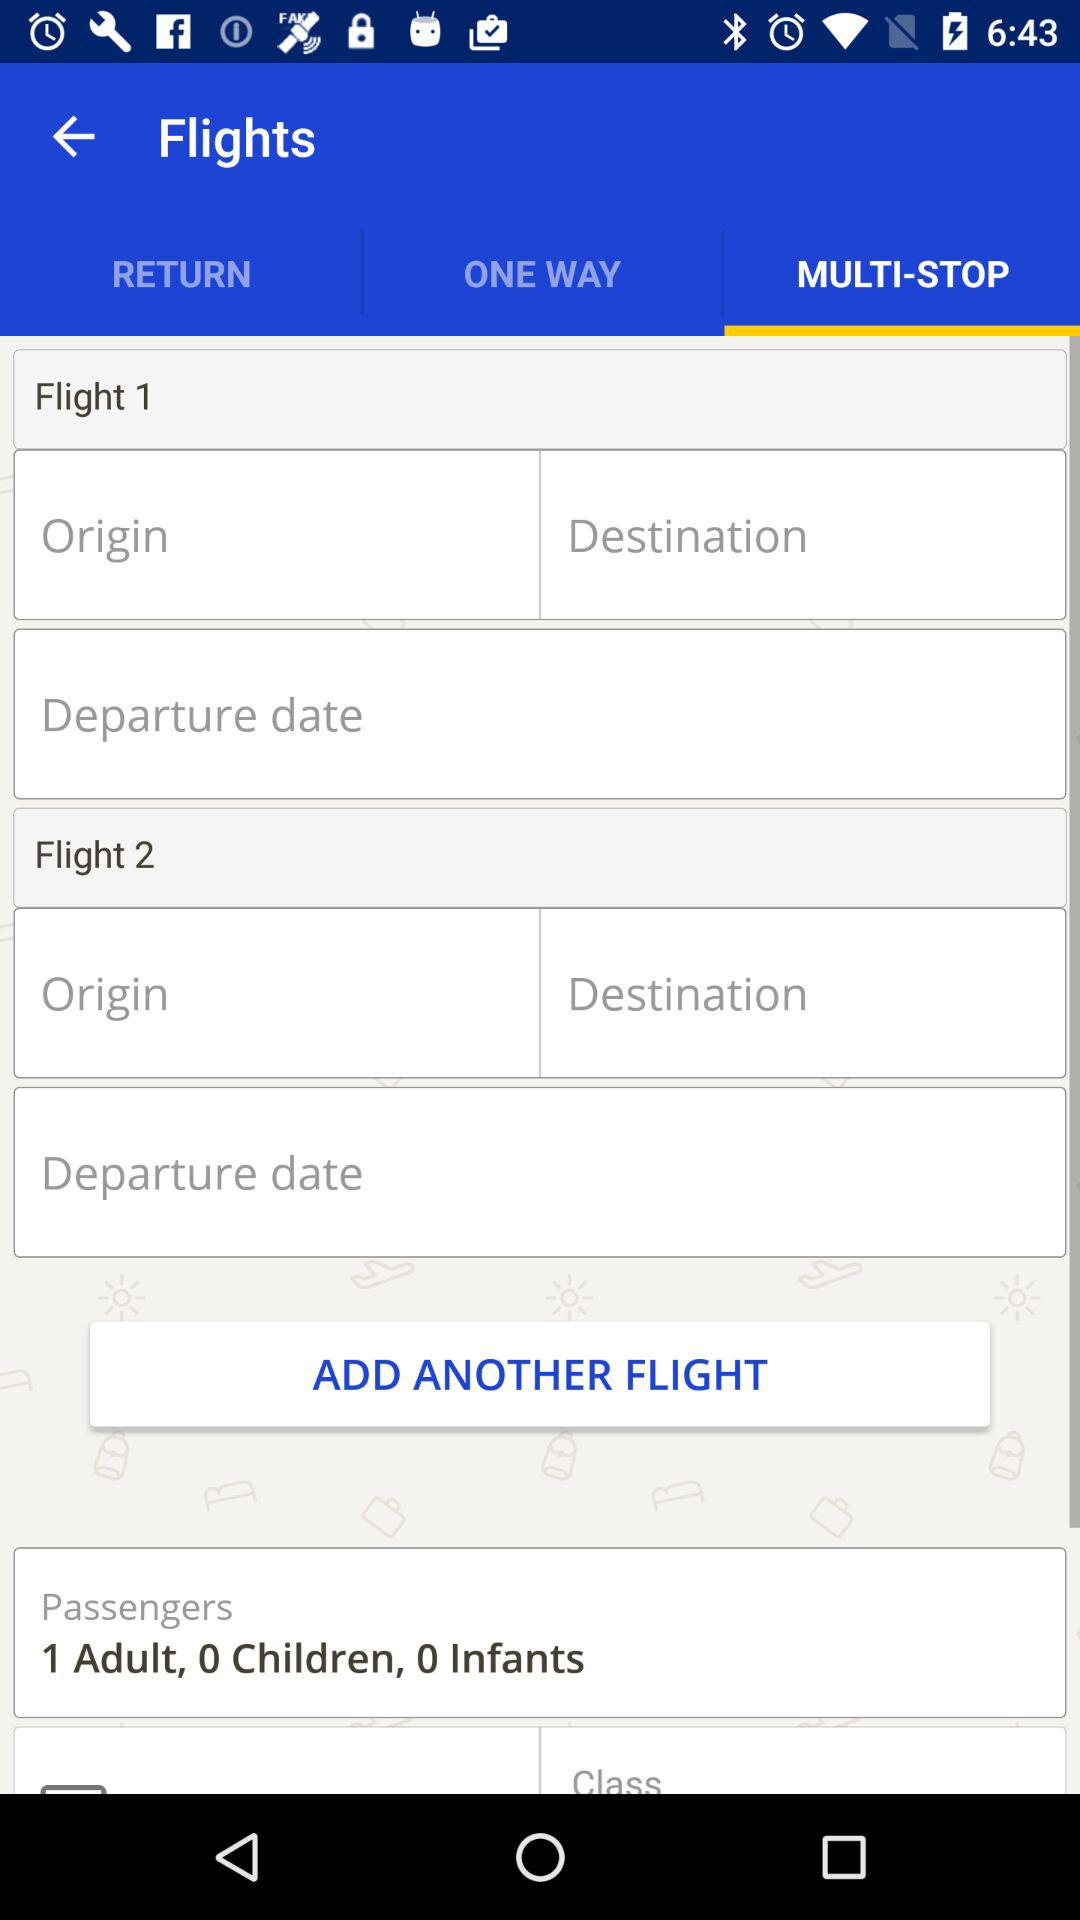Which option is selected? The selected option is "MULTI-STOP". 